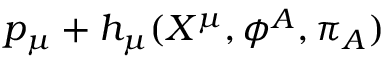Convert formula to latex. <formula><loc_0><loc_0><loc_500><loc_500>p _ { \mu } + h _ { \mu } ( X ^ { \mu } , \phi ^ { A } , \pi _ { A } )</formula> 